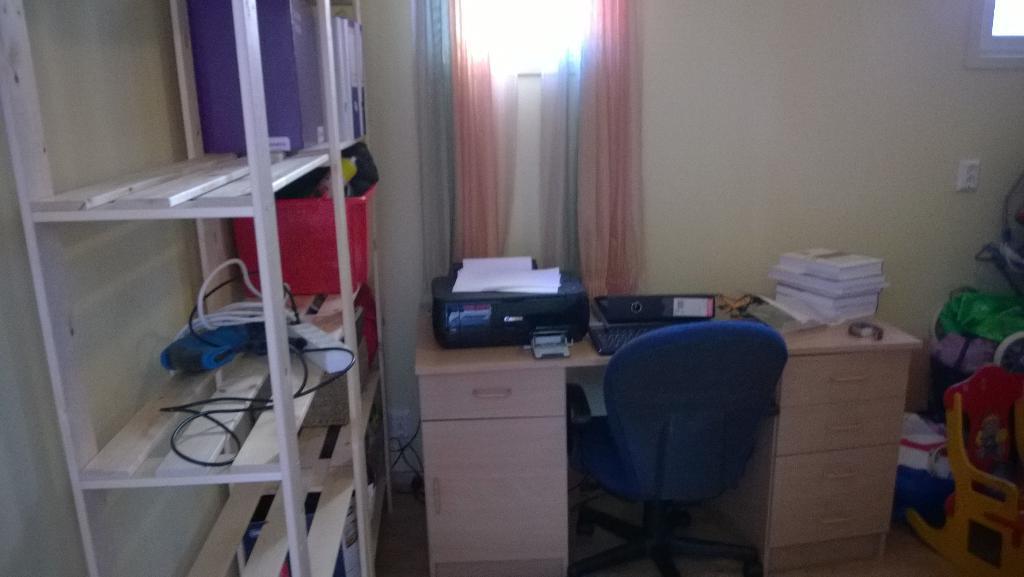In one or two sentences, can you explain what this image depicts? It is a room inside the house , there is a computer table on which a keyboard , some files ,books and a printer are kept, there is also a blue color chair in front of the table, to the left side there is a cupboard like thing on which some adapters, wires , a red color tub and also some files are kept, to the right side there is a curtain and in the background there is a cream color wall. 